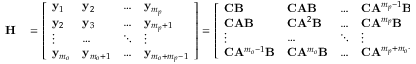Convert formula to latex. <formula><loc_0><loc_0><loc_500><loc_500>\begin{array} { r l } { H } & = \left [ \begin{array} { l l l l } { y _ { 1 } } & { y _ { 2 } } & { \dots } & { y _ { m _ { p } } } \\ { y _ { 2 } } & { y _ { 3 } } & { \dots } & { y _ { m _ { p } + 1 } } \\ { \vdots } & { \dots } & { \ddots } & { \vdots } \\ { y _ { m _ { o } } } & { y _ { m _ { o } + 1 } } & { \dots } & { y _ { m _ { o } + m _ { p } - 1 } } \end{array} \right ] = \left [ \begin{array} { l l l l } { C B } & { C A B } & { \dots } & { C A ^ { m _ { p } - 1 } B } \\ { C A B } & { C A ^ { 2 } B } & { \dots } & { C A ^ { m _ { p } } B } \\ { \vdots } & { \dots } & { \ddots } & { \vdots } \\ { C A ^ { m _ { o } - 1 } B } & { C A ^ { m _ { o } } B } & { \dots } & { C A ^ { m _ { p } + m _ { o } - 2 } B } \end{array} \right ] , } \end{array}</formula> 